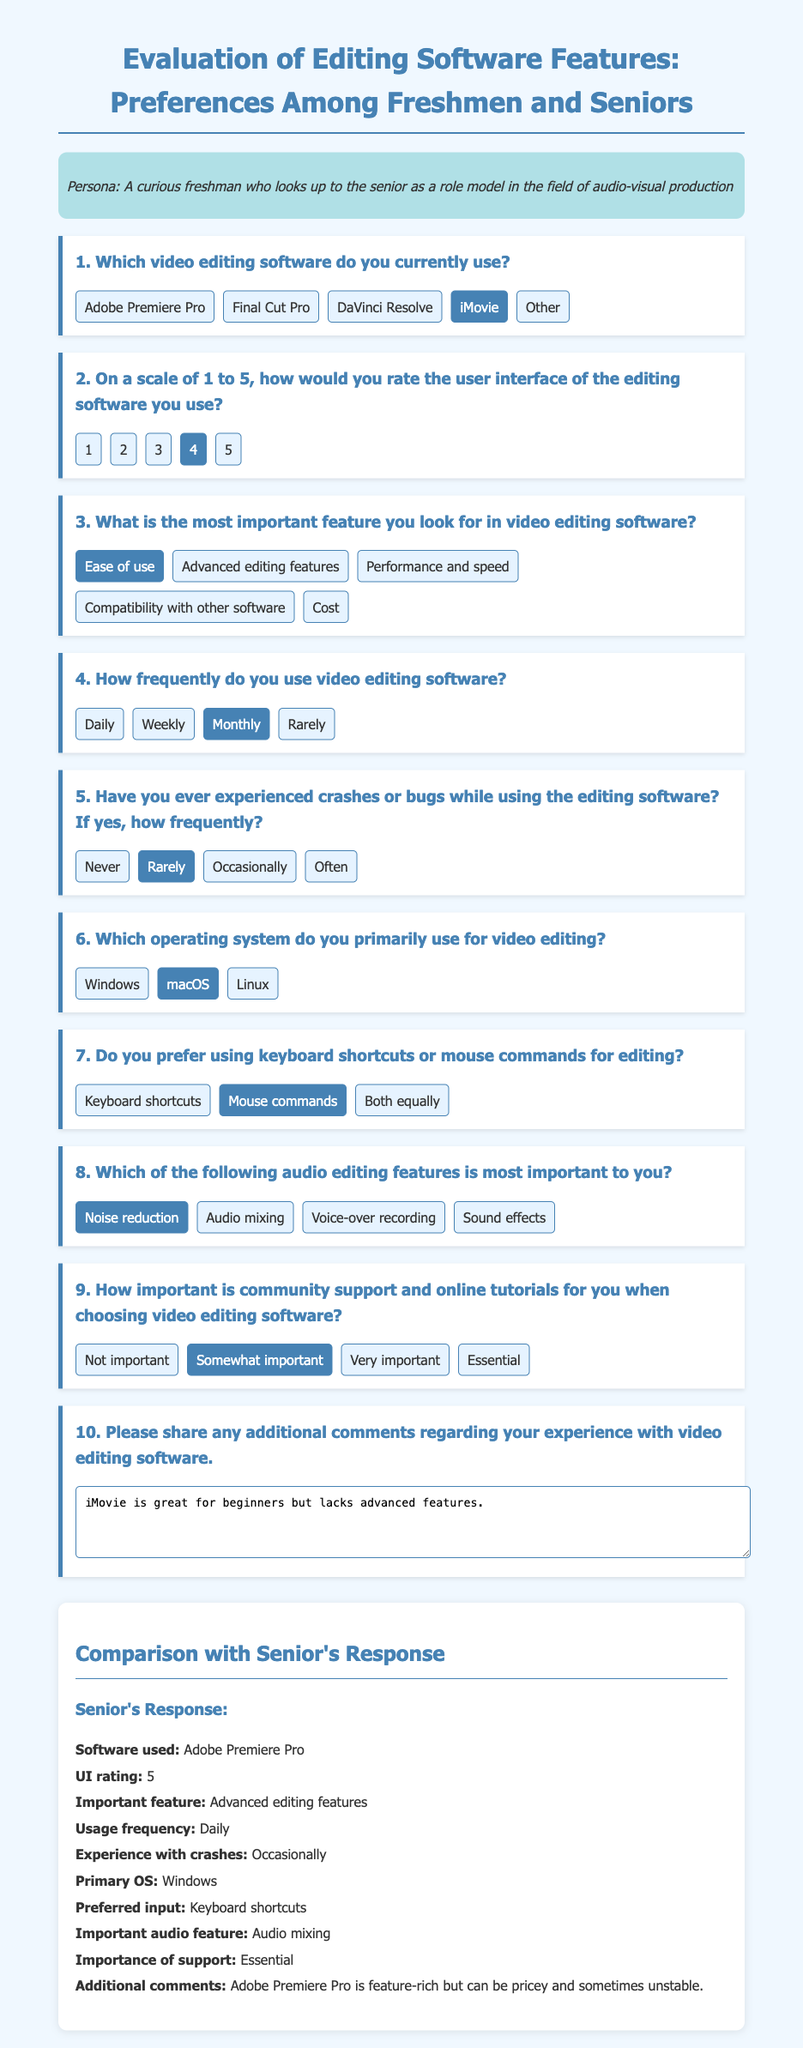What video editing software does the freshman use? The document states that the freshman currently uses iMovie for video editing.
Answer: iMovie How would the freshman rate the user interface of their editing software? According to the document, the freshman rates the user interface as a 4 on a scale of 1 to 5.
Answer: 4 What is the most important feature for the freshman when choosing editing software? The document indicates that the freshman looks for ease of use as the most important feature.
Answer: Ease of use How frequently does the freshman use video editing software? The information provided shows that the freshman uses video editing software monthly.
Answer: Monthly What audio editing feature is prioritized by the freshman? The freshman considers noise reduction to be the most important audio editing feature according to the document.
Answer: Noise reduction What software does the senior use for video editing? The document specifies that the senior uses Adobe Premiere Pro for editing.
Answer: Adobe Premiere Pro What is the senior's rating for the user interface of their editing software? The senior rated the user interface of their editing software as a 5.
Answer: 5 How often does the senior experience crashes while using their editing software? The senior experiences crashes occasionally, as stated in the document.
Answer: Occasionally What additional comment did the senior provide about their editing software? The senior mentions that Adobe Premiere Pro is feature-rich but can be pricey and sometimes unstable.
Answer: Adobe Premiere Pro is feature-rich but can be pricey and sometimes unstable 